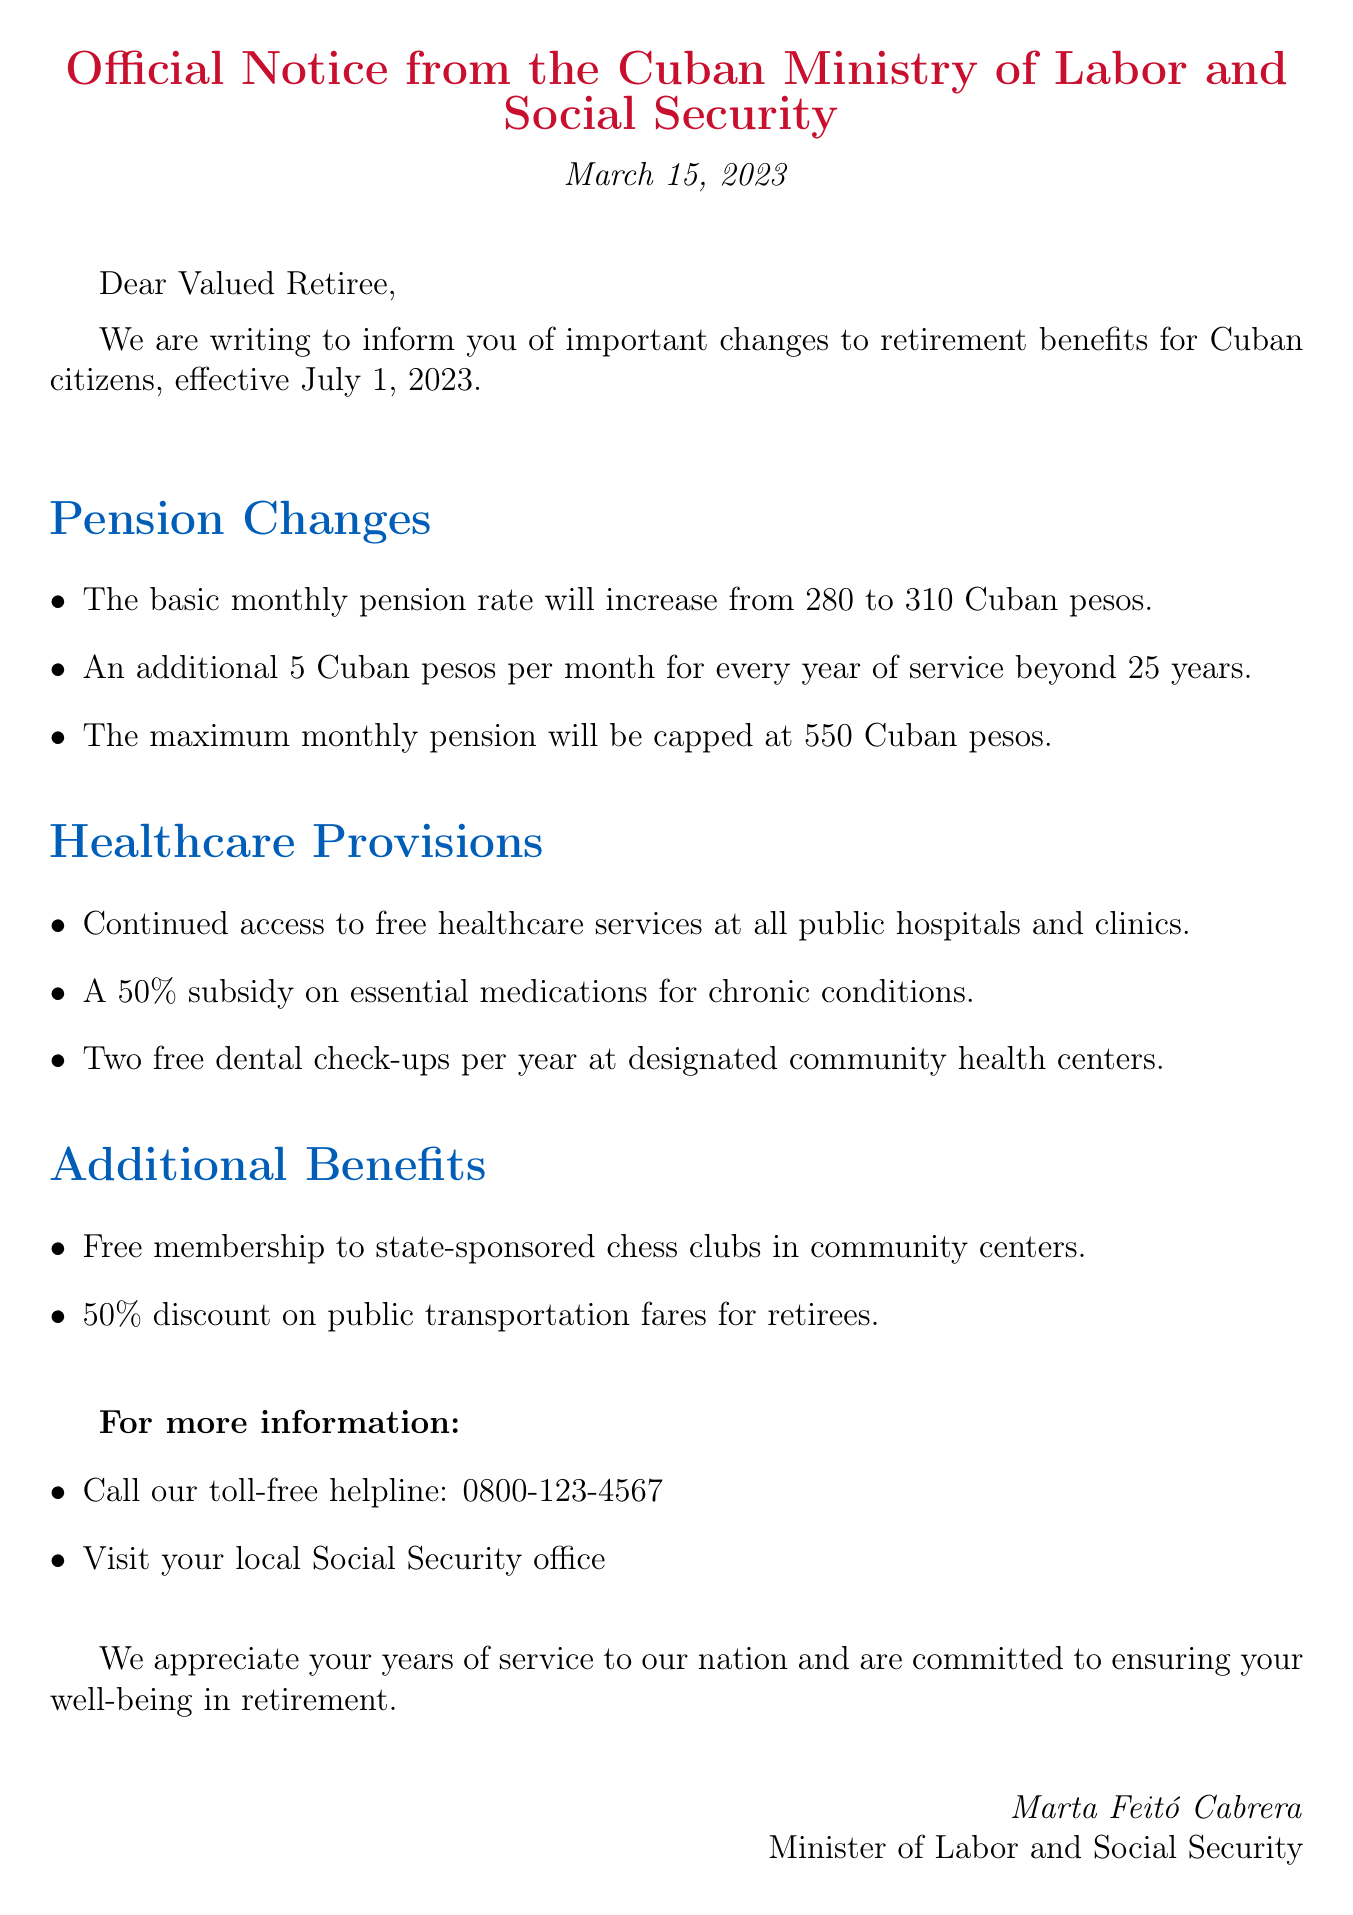What is the new basic monthly pension rate? The basic monthly pension rate has increased, as stated in the document, which indicates the previous and new rates.
Answer: 310 Cuban pesos What is the additional amount provided for years of service beyond 25 years? The document specifies an additional amount added to the basic pension for each year of service exceeding 25 years.
Answer: 5 Cuban pesos What is the maximum monthly pension cap? The maximum monthly pension is a defined limit mentioned in the document, which restricts the pension amount.
Answer: 550 Cuban pesos How many free dental check-ups are retirees entitled to each year? The document lists the number of dental check-ups offered to retirees at specific health centers annually.
Answer: Two What percentage is the subsidy on essential medications for chronic conditions? The document notes a percentage subsidy offered on medications for those with chronic health issues.
Answer: 50% What type of clubs can retirees get free membership to? The document specifies a particular type of club that is available for free membership to retirees.
Answer: State-sponsored chess clubs What is the date the changes to retirement benefits will take effect? The document includes a date when the upcoming retirement benefits changes become active.
Answer: July 1, 2023 What should retirees do for more information? The document suggests a course of action for retirees seeking additional details regarding their retirement benefits.
Answer: Visit your local Social Security office What is the closing message from the Minister? The document contains a closing statement expressing gratitude and commitment from the Minister of Labor and Social Security.
Answer: We appreciate your years of service to our nation and are committed to ensuring your well-being in retirement 